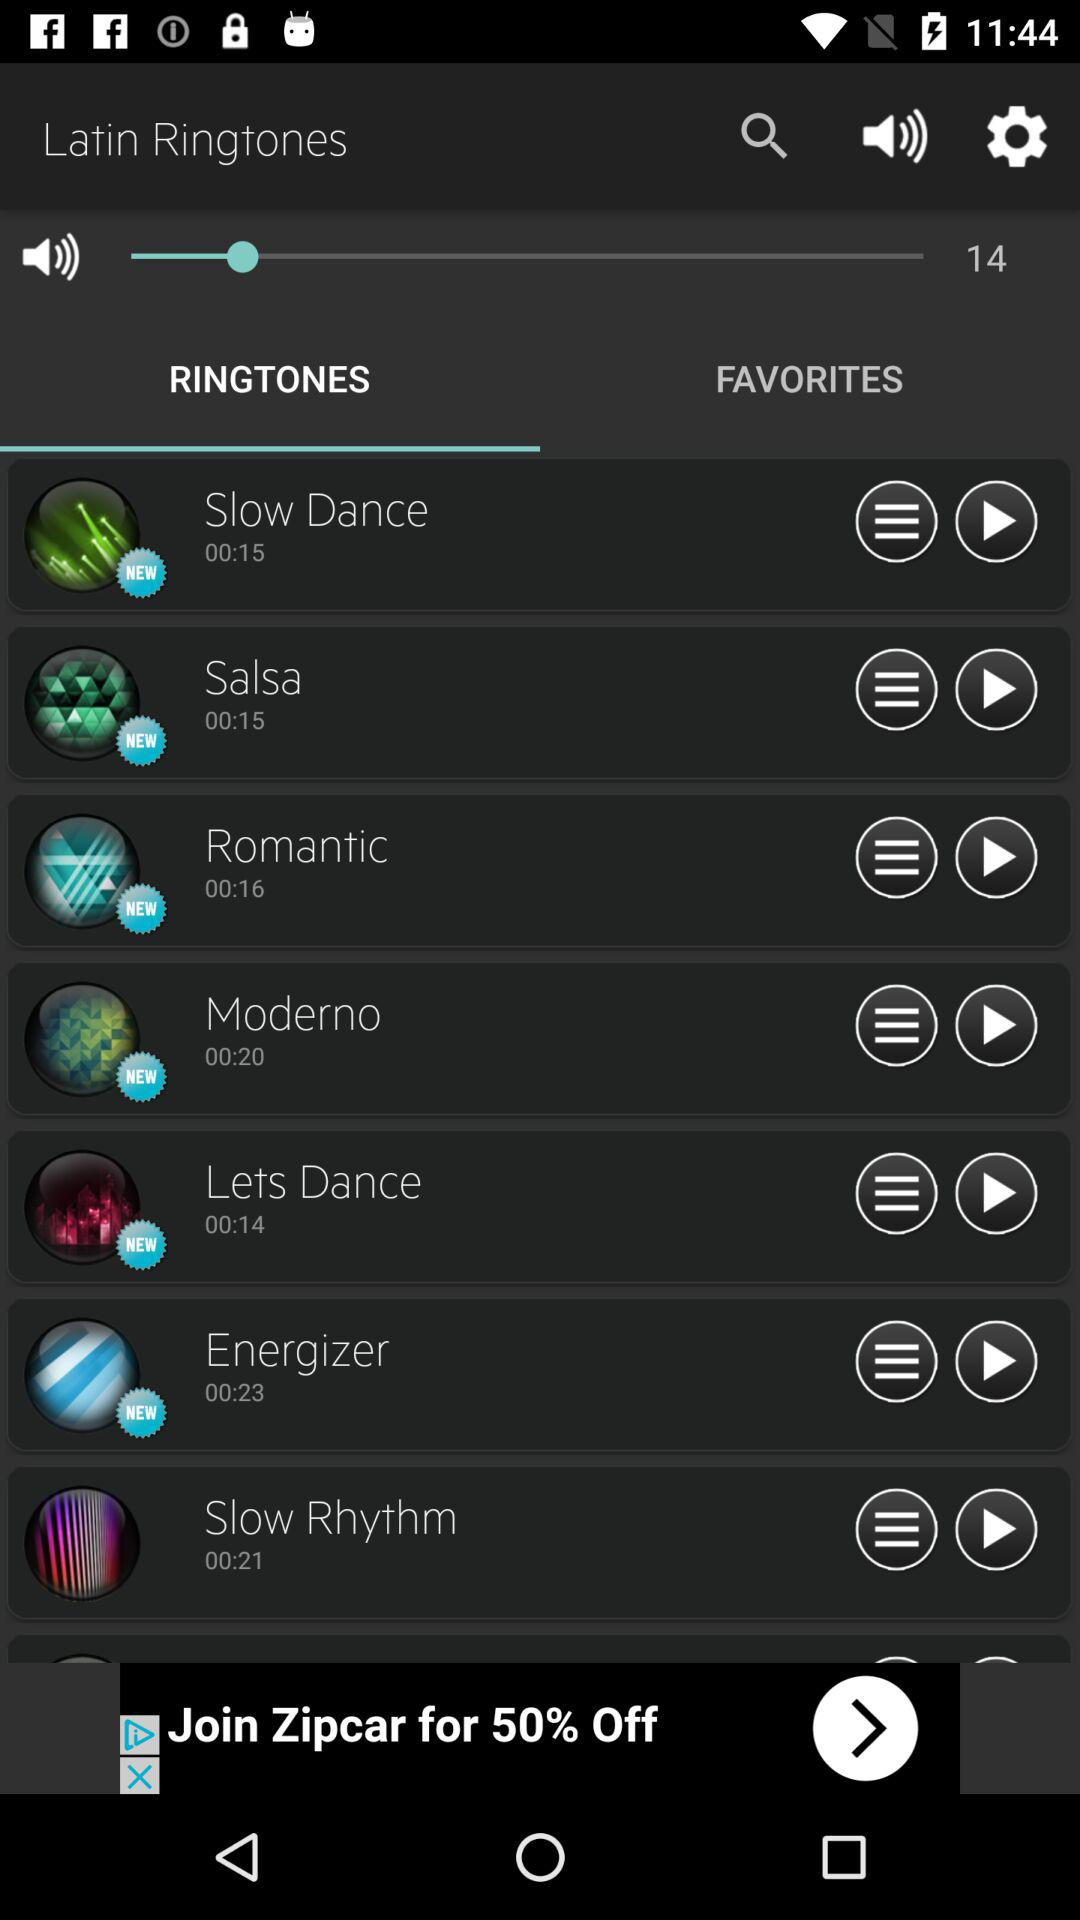Which option has been selected in "Latin Ringtones"? The selected option is "RINGTONES". 